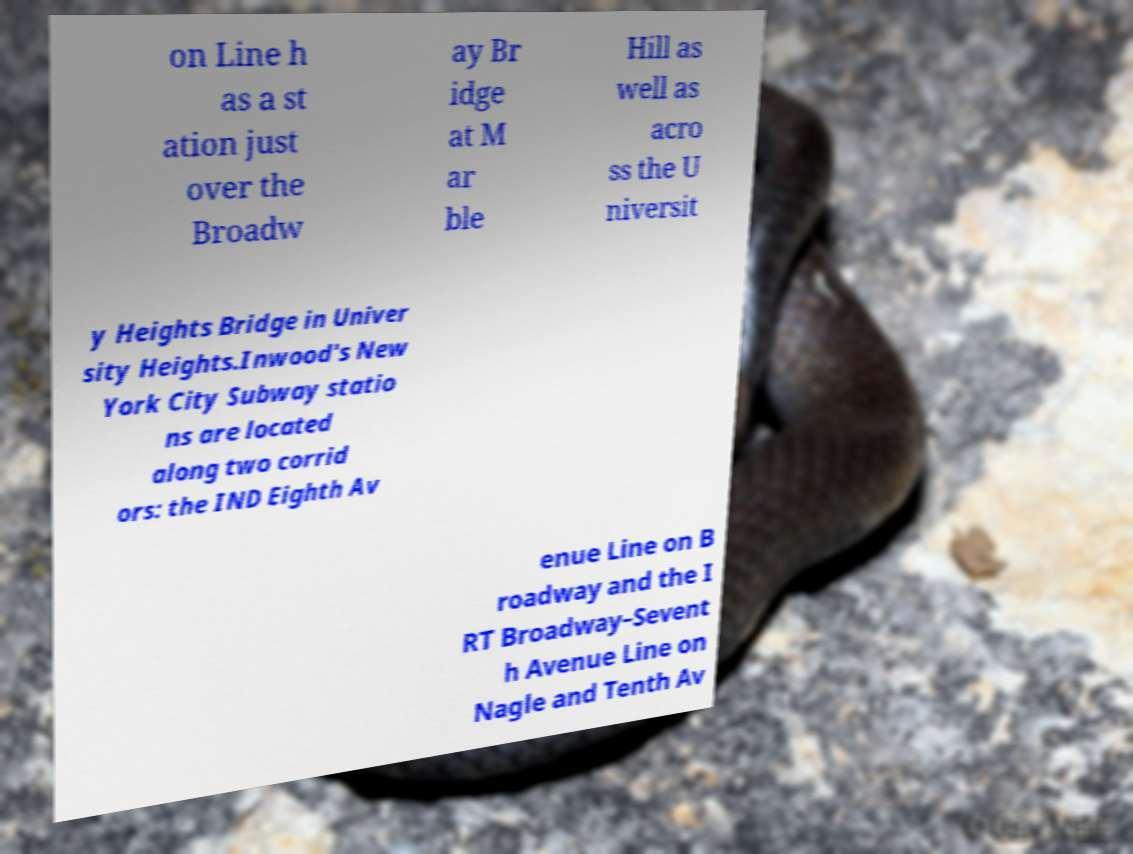I need the written content from this picture converted into text. Can you do that? on Line h as a st ation just over the Broadw ay Br idge at M ar ble Hill as well as acro ss the U niversit y Heights Bridge in Univer sity Heights.Inwood's New York City Subway statio ns are located along two corrid ors: the IND Eighth Av enue Line on B roadway and the I RT Broadway–Sevent h Avenue Line on Nagle and Tenth Av 